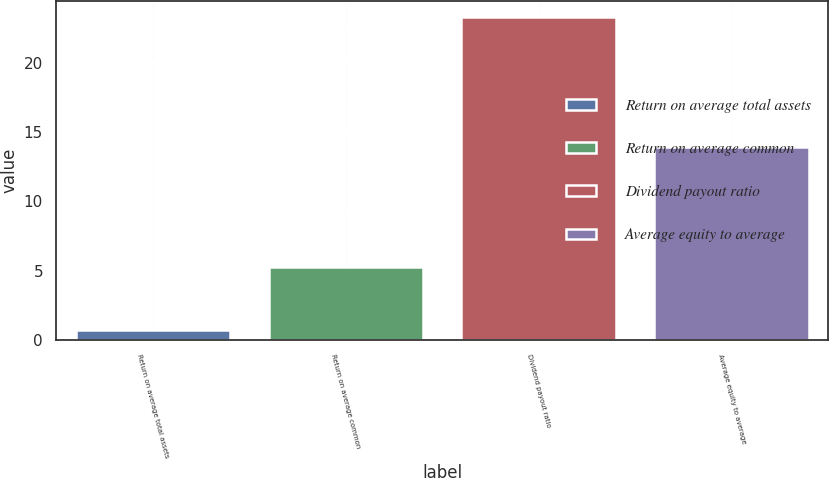Convert chart to OTSL. <chart><loc_0><loc_0><loc_500><loc_500><bar_chart><fcel>Return on average total assets<fcel>Return on average common<fcel>Dividend payout ratio<fcel>Average equity to average<nl><fcel>0.73<fcel>5.23<fcel>23.3<fcel>13.93<nl></chart> 